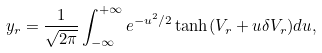Convert formula to latex. <formula><loc_0><loc_0><loc_500><loc_500>y _ { r } = \frac { 1 } { \sqrt { 2 \pi } } \int _ { - \infty } ^ { + \infty } e ^ { - u ^ { 2 } / 2 } \tanh ( V _ { r } + u \delta V _ { r } ) d u ,</formula> 